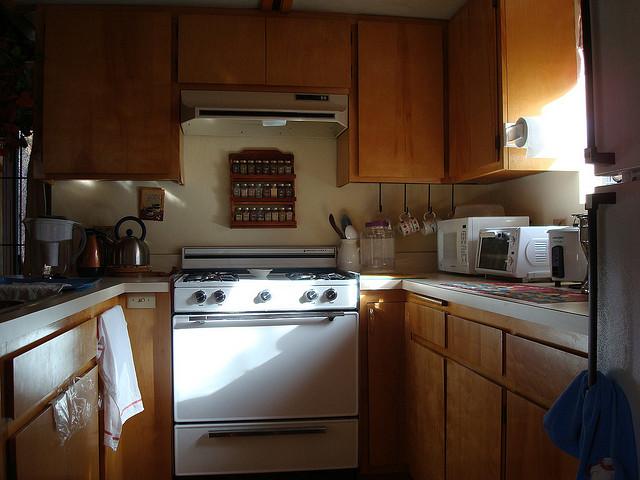Are the lights on?
Keep it brief. No. Where is the spice rack?
Answer briefly. Above stove. Is it dark outside in this image?
Concise answer only. No. What color is the stove?
Keep it brief. White. 